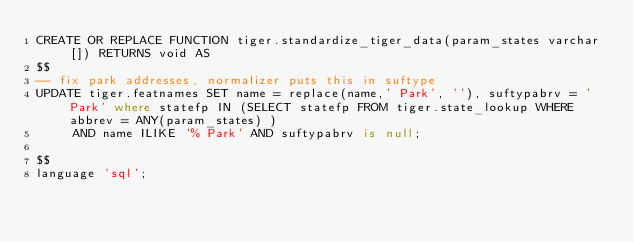Convert code to text. <code><loc_0><loc_0><loc_500><loc_500><_SQL_>CREATE OR REPLACE FUNCTION tiger.standardize_tiger_data(param_states varchar[]) RETURNS void AS
$$
-- fix park addresses, normalizer puts this in suftype
UPDATE tiger.featnames SET name = replace(name,' Park', ''), suftypabrv = 'Park' where statefp IN (SELECT statefp FROM tiger.state_lookup WHERE abbrev = ANY(param_states) ) 
     AND name ILIKE '% Park' AND suftypabrv is null;

$$
language 'sql';</code> 